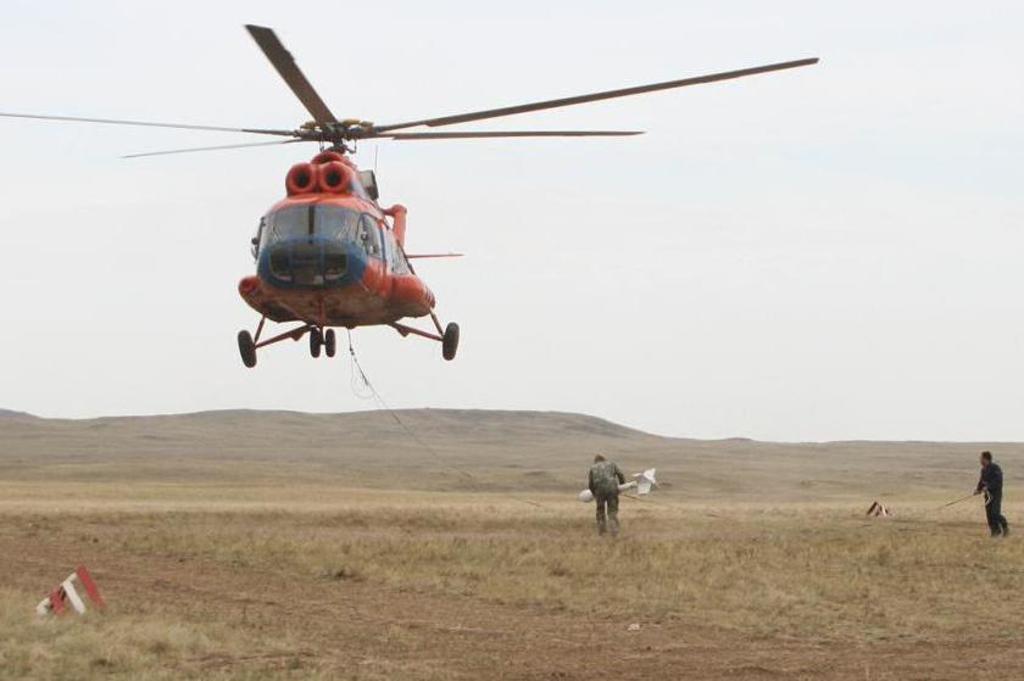Describe this image in one or two sentences. In this image, we can see persons wearing clothes. There is a helicopter above the ground. In the background of the image, there is a sky. 